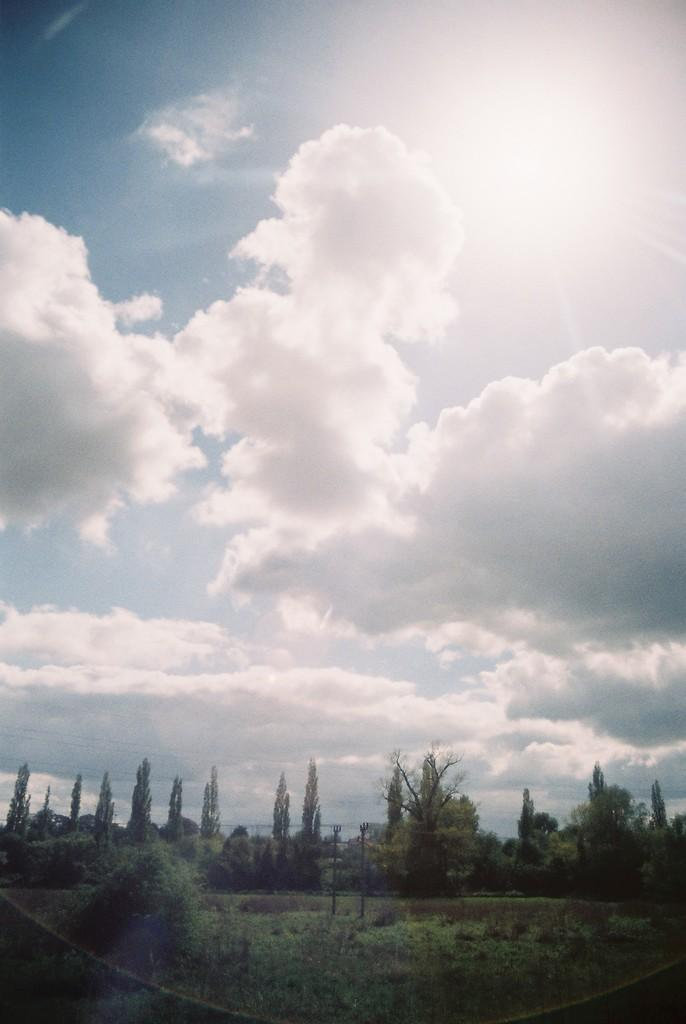What type of vegetation can be seen in the image? There are plants and trees in the image. What is covering the ground in the image? There is grass on the ground in the image. What can be seen in the background of the image? There are clouds and the sun visible in the sky in the background of the image. What is the price of the corn in the image? There is no corn present in the image, so it is not possible to determine its price. 